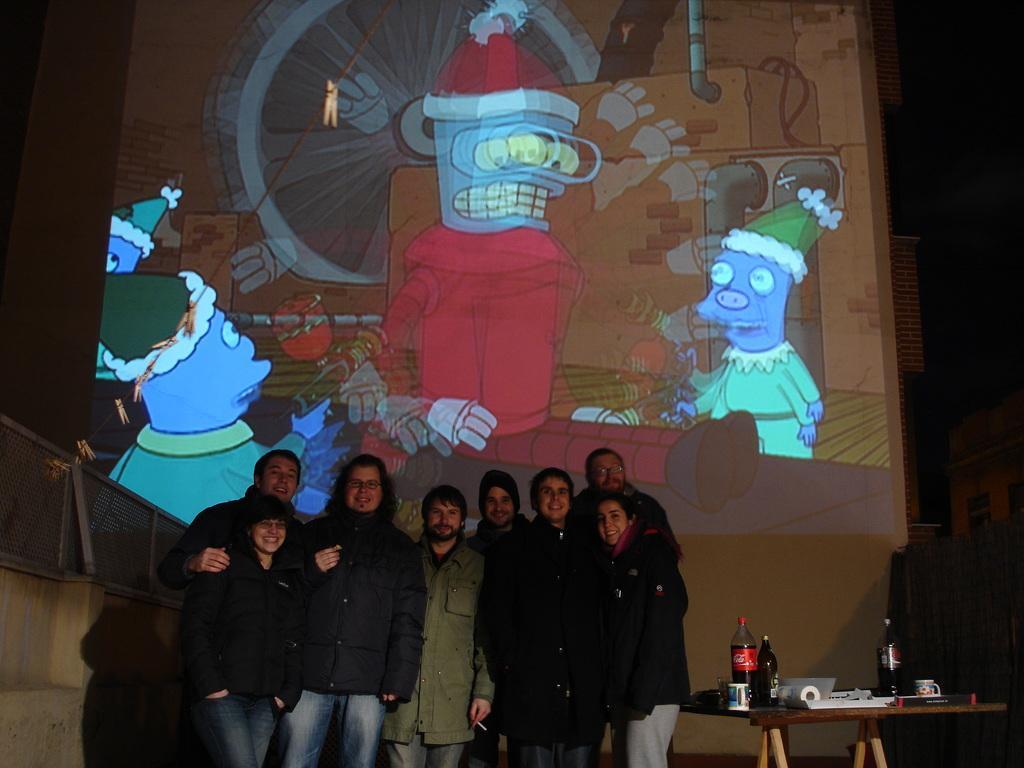Please provide a concise description of this image. There is a group of people. They are standing and they are smiling. There is a table on the right side. There is a bottle,papers on a table. We can see in the background cartoon poster. 